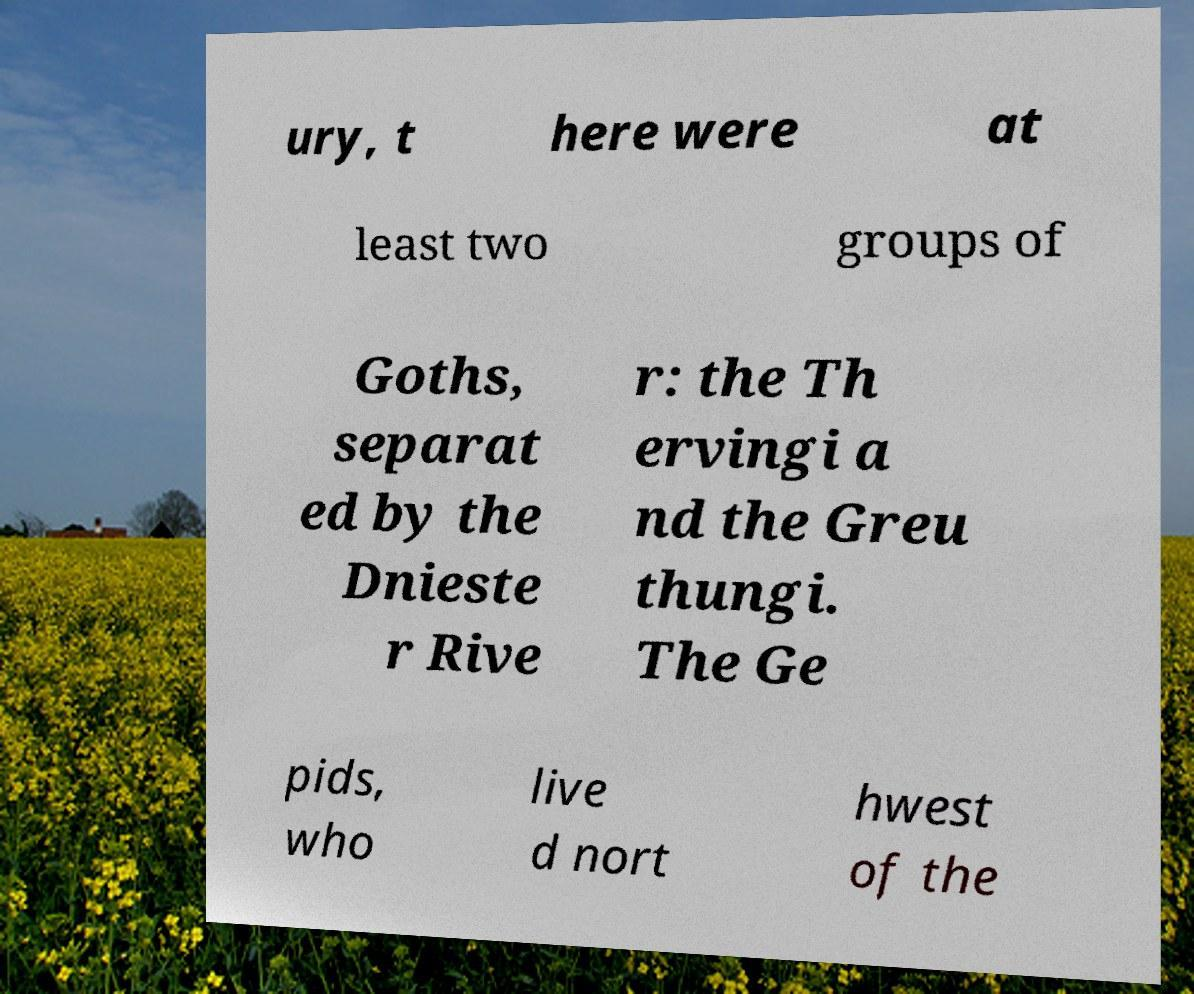Can you accurately transcribe the text from the provided image for me? ury, t here were at least two groups of Goths, separat ed by the Dnieste r Rive r: the Th ervingi a nd the Greu thungi. The Ge pids, who live d nort hwest of the 